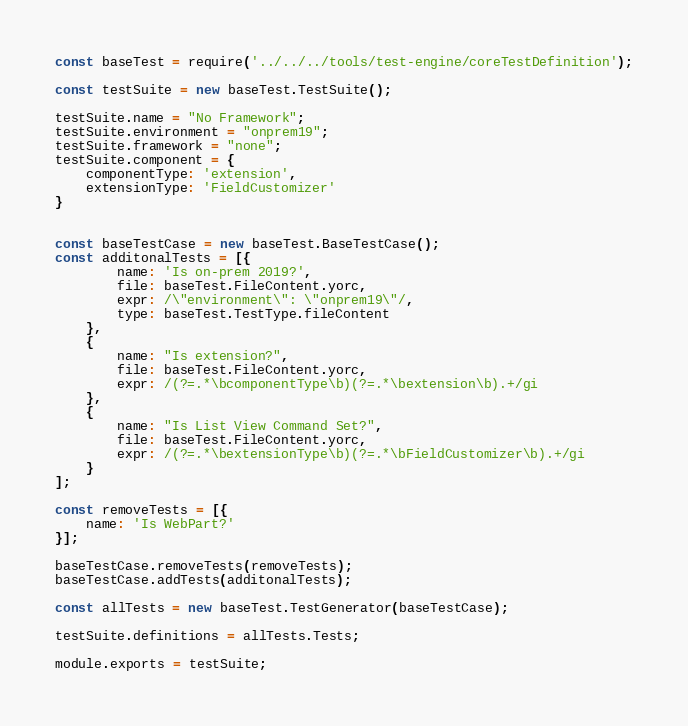<code> <loc_0><loc_0><loc_500><loc_500><_JavaScript_>const baseTest = require('../../../tools/test-engine/coreTestDefinition');

const testSuite = new baseTest.TestSuite();

testSuite.name = "No Framework";
testSuite.environment = "onprem19";
testSuite.framework = "none";
testSuite.component = {
    componentType: 'extension',
    extensionType: 'FieldCustomizer'
}


const baseTestCase = new baseTest.BaseTestCase();
const additonalTests = [{
        name: 'Is on-prem 2019?',
        file: baseTest.FileContent.yorc,
        expr: /\"environment\": \"onprem19\"/,
        type: baseTest.TestType.fileContent
    },
    {
        name: "Is extension?",
        file: baseTest.FileContent.yorc,
        expr: /(?=.*\bcomponentType\b)(?=.*\bextension\b).+/gi
    },
    {
        name: "Is List View Command Set?",
        file: baseTest.FileContent.yorc,
        expr: /(?=.*\bextensionType\b)(?=.*\bFieldCustomizer\b).+/gi
    }
];

const removeTests = [{
    name: 'Is WebPart?'
}];

baseTestCase.removeTests(removeTests);
baseTestCase.addTests(additonalTests);

const allTests = new baseTest.TestGenerator(baseTestCase);

testSuite.definitions = allTests.Tests;

module.exports = testSuite;
</code> 